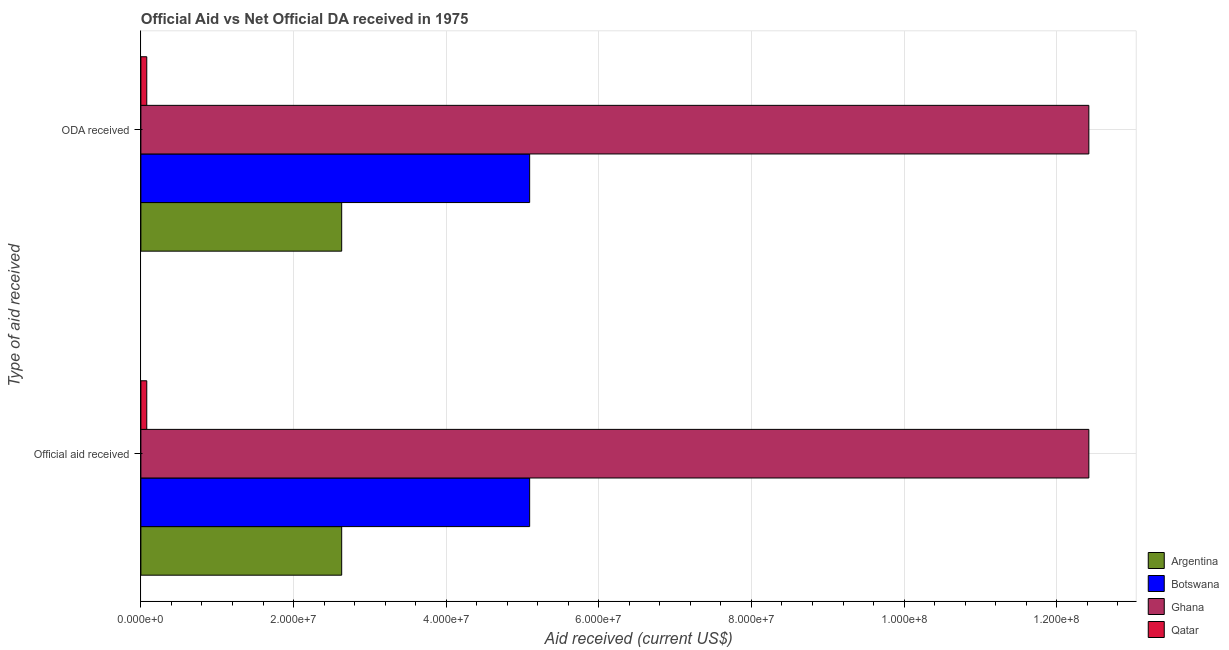How many different coloured bars are there?
Provide a short and direct response. 4. Are the number of bars per tick equal to the number of legend labels?
Give a very brief answer. Yes. Are the number of bars on each tick of the Y-axis equal?
Ensure brevity in your answer.  Yes. How many bars are there on the 1st tick from the bottom?
Keep it short and to the point. 4. What is the label of the 2nd group of bars from the top?
Ensure brevity in your answer.  Official aid received. What is the official aid received in Botswana?
Your answer should be compact. 5.09e+07. Across all countries, what is the maximum official aid received?
Offer a very short reply. 1.24e+08. Across all countries, what is the minimum official aid received?
Offer a very short reply. 7.70e+05. In which country was the official aid received maximum?
Keep it short and to the point. Ghana. In which country was the official aid received minimum?
Your response must be concise. Qatar. What is the total oda received in the graph?
Offer a very short reply. 2.02e+08. What is the difference between the oda received in Botswana and that in Argentina?
Offer a terse response. 2.46e+07. What is the difference between the official aid received in Botswana and the oda received in Qatar?
Your response must be concise. 5.02e+07. What is the average oda received per country?
Provide a succinct answer. 5.06e+07. What is the ratio of the oda received in Qatar to that in Argentina?
Offer a very short reply. 0.03. In how many countries, is the official aid received greater than the average official aid received taken over all countries?
Give a very brief answer. 2. What does the 1st bar from the top in ODA received represents?
Your answer should be compact. Qatar. Are all the bars in the graph horizontal?
Provide a short and direct response. Yes. How many countries are there in the graph?
Make the answer very short. 4. What is the difference between two consecutive major ticks on the X-axis?
Make the answer very short. 2.00e+07. Where does the legend appear in the graph?
Your response must be concise. Bottom right. How are the legend labels stacked?
Give a very brief answer. Vertical. What is the title of the graph?
Your response must be concise. Official Aid vs Net Official DA received in 1975 . What is the label or title of the X-axis?
Ensure brevity in your answer.  Aid received (current US$). What is the label or title of the Y-axis?
Offer a very short reply. Type of aid received. What is the Aid received (current US$) of Argentina in Official aid received?
Offer a very short reply. 2.63e+07. What is the Aid received (current US$) of Botswana in Official aid received?
Give a very brief answer. 5.09e+07. What is the Aid received (current US$) of Ghana in Official aid received?
Make the answer very short. 1.24e+08. What is the Aid received (current US$) of Qatar in Official aid received?
Give a very brief answer. 7.70e+05. What is the Aid received (current US$) of Argentina in ODA received?
Give a very brief answer. 2.63e+07. What is the Aid received (current US$) in Botswana in ODA received?
Offer a terse response. 5.09e+07. What is the Aid received (current US$) of Ghana in ODA received?
Your answer should be very brief. 1.24e+08. What is the Aid received (current US$) of Qatar in ODA received?
Provide a succinct answer. 7.70e+05. Across all Type of aid received, what is the maximum Aid received (current US$) in Argentina?
Make the answer very short. 2.63e+07. Across all Type of aid received, what is the maximum Aid received (current US$) of Botswana?
Your answer should be very brief. 5.09e+07. Across all Type of aid received, what is the maximum Aid received (current US$) of Ghana?
Your answer should be compact. 1.24e+08. Across all Type of aid received, what is the maximum Aid received (current US$) in Qatar?
Make the answer very short. 7.70e+05. Across all Type of aid received, what is the minimum Aid received (current US$) of Argentina?
Your answer should be very brief. 2.63e+07. Across all Type of aid received, what is the minimum Aid received (current US$) of Botswana?
Offer a very short reply. 5.09e+07. Across all Type of aid received, what is the minimum Aid received (current US$) in Ghana?
Offer a very short reply. 1.24e+08. Across all Type of aid received, what is the minimum Aid received (current US$) of Qatar?
Keep it short and to the point. 7.70e+05. What is the total Aid received (current US$) in Argentina in the graph?
Provide a short and direct response. 5.26e+07. What is the total Aid received (current US$) in Botswana in the graph?
Offer a terse response. 1.02e+08. What is the total Aid received (current US$) in Ghana in the graph?
Provide a short and direct response. 2.48e+08. What is the total Aid received (current US$) of Qatar in the graph?
Your answer should be very brief. 1.54e+06. What is the difference between the Aid received (current US$) in Argentina in Official aid received and that in ODA received?
Offer a terse response. 0. What is the difference between the Aid received (current US$) in Ghana in Official aid received and that in ODA received?
Your response must be concise. 0. What is the difference between the Aid received (current US$) in Argentina in Official aid received and the Aid received (current US$) in Botswana in ODA received?
Give a very brief answer. -2.46e+07. What is the difference between the Aid received (current US$) of Argentina in Official aid received and the Aid received (current US$) of Ghana in ODA received?
Your answer should be compact. -9.79e+07. What is the difference between the Aid received (current US$) in Argentina in Official aid received and the Aid received (current US$) in Qatar in ODA received?
Provide a short and direct response. 2.55e+07. What is the difference between the Aid received (current US$) in Botswana in Official aid received and the Aid received (current US$) in Ghana in ODA received?
Keep it short and to the point. -7.33e+07. What is the difference between the Aid received (current US$) of Botswana in Official aid received and the Aid received (current US$) of Qatar in ODA received?
Offer a terse response. 5.02e+07. What is the difference between the Aid received (current US$) of Ghana in Official aid received and the Aid received (current US$) of Qatar in ODA received?
Make the answer very short. 1.23e+08. What is the average Aid received (current US$) in Argentina per Type of aid received?
Offer a very short reply. 2.63e+07. What is the average Aid received (current US$) in Botswana per Type of aid received?
Your answer should be very brief. 5.09e+07. What is the average Aid received (current US$) in Ghana per Type of aid received?
Offer a very short reply. 1.24e+08. What is the average Aid received (current US$) in Qatar per Type of aid received?
Give a very brief answer. 7.70e+05. What is the difference between the Aid received (current US$) of Argentina and Aid received (current US$) of Botswana in Official aid received?
Your response must be concise. -2.46e+07. What is the difference between the Aid received (current US$) of Argentina and Aid received (current US$) of Ghana in Official aid received?
Your answer should be compact. -9.79e+07. What is the difference between the Aid received (current US$) in Argentina and Aid received (current US$) in Qatar in Official aid received?
Keep it short and to the point. 2.55e+07. What is the difference between the Aid received (current US$) in Botswana and Aid received (current US$) in Ghana in Official aid received?
Offer a terse response. -7.33e+07. What is the difference between the Aid received (current US$) of Botswana and Aid received (current US$) of Qatar in Official aid received?
Provide a short and direct response. 5.02e+07. What is the difference between the Aid received (current US$) in Ghana and Aid received (current US$) in Qatar in Official aid received?
Your answer should be compact. 1.23e+08. What is the difference between the Aid received (current US$) in Argentina and Aid received (current US$) in Botswana in ODA received?
Keep it short and to the point. -2.46e+07. What is the difference between the Aid received (current US$) of Argentina and Aid received (current US$) of Ghana in ODA received?
Provide a short and direct response. -9.79e+07. What is the difference between the Aid received (current US$) in Argentina and Aid received (current US$) in Qatar in ODA received?
Ensure brevity in your answer.  2.55e+07. What is the difference between the Aid received (current US$) in Botswana and Aid received (current US$) in Ghana in ODA received?
Give a very brief answer. -7.33e+07. What is the difference between the Aid received (current US$) of Botswana and Aid received (current US$) of Qatar in ODA received?
Offer a very short reply. 5.02e+07. What is the difference between the Aid received (current US$) of Ghana and Aid received (current US$) of Qatar in ODA received?
Make the answer very short. 1.23e+08. What is the ratio of the Aid received (current US$) in Qatar in Official aid received to that in ODA received?
Provide a short and direct response. 1. What is the difference between the highest and the second highest Aid received (current US$) in Argentina?
Provide a succinct answer. 0. What is the difference between the highest and the second highest Aid received (current US$) of Botswana?
Your answer should be very brief. 0. What is the difference between the highest and the second highest Aid received (current US$) in Ghana?
Keep it short and to the point. 0. What is the difference between the highest and the second highest Aid received (current US$) of Qatar?
Give a very brief answer. 0. What is the difference between the highest and the lowest Aid received (current US$) in Argentina?
Ensure brevity in your answer.  0. What is the difference between the highest and the lowest Aid received (current US$) in Qatar?
Your response must be concise. 0. 